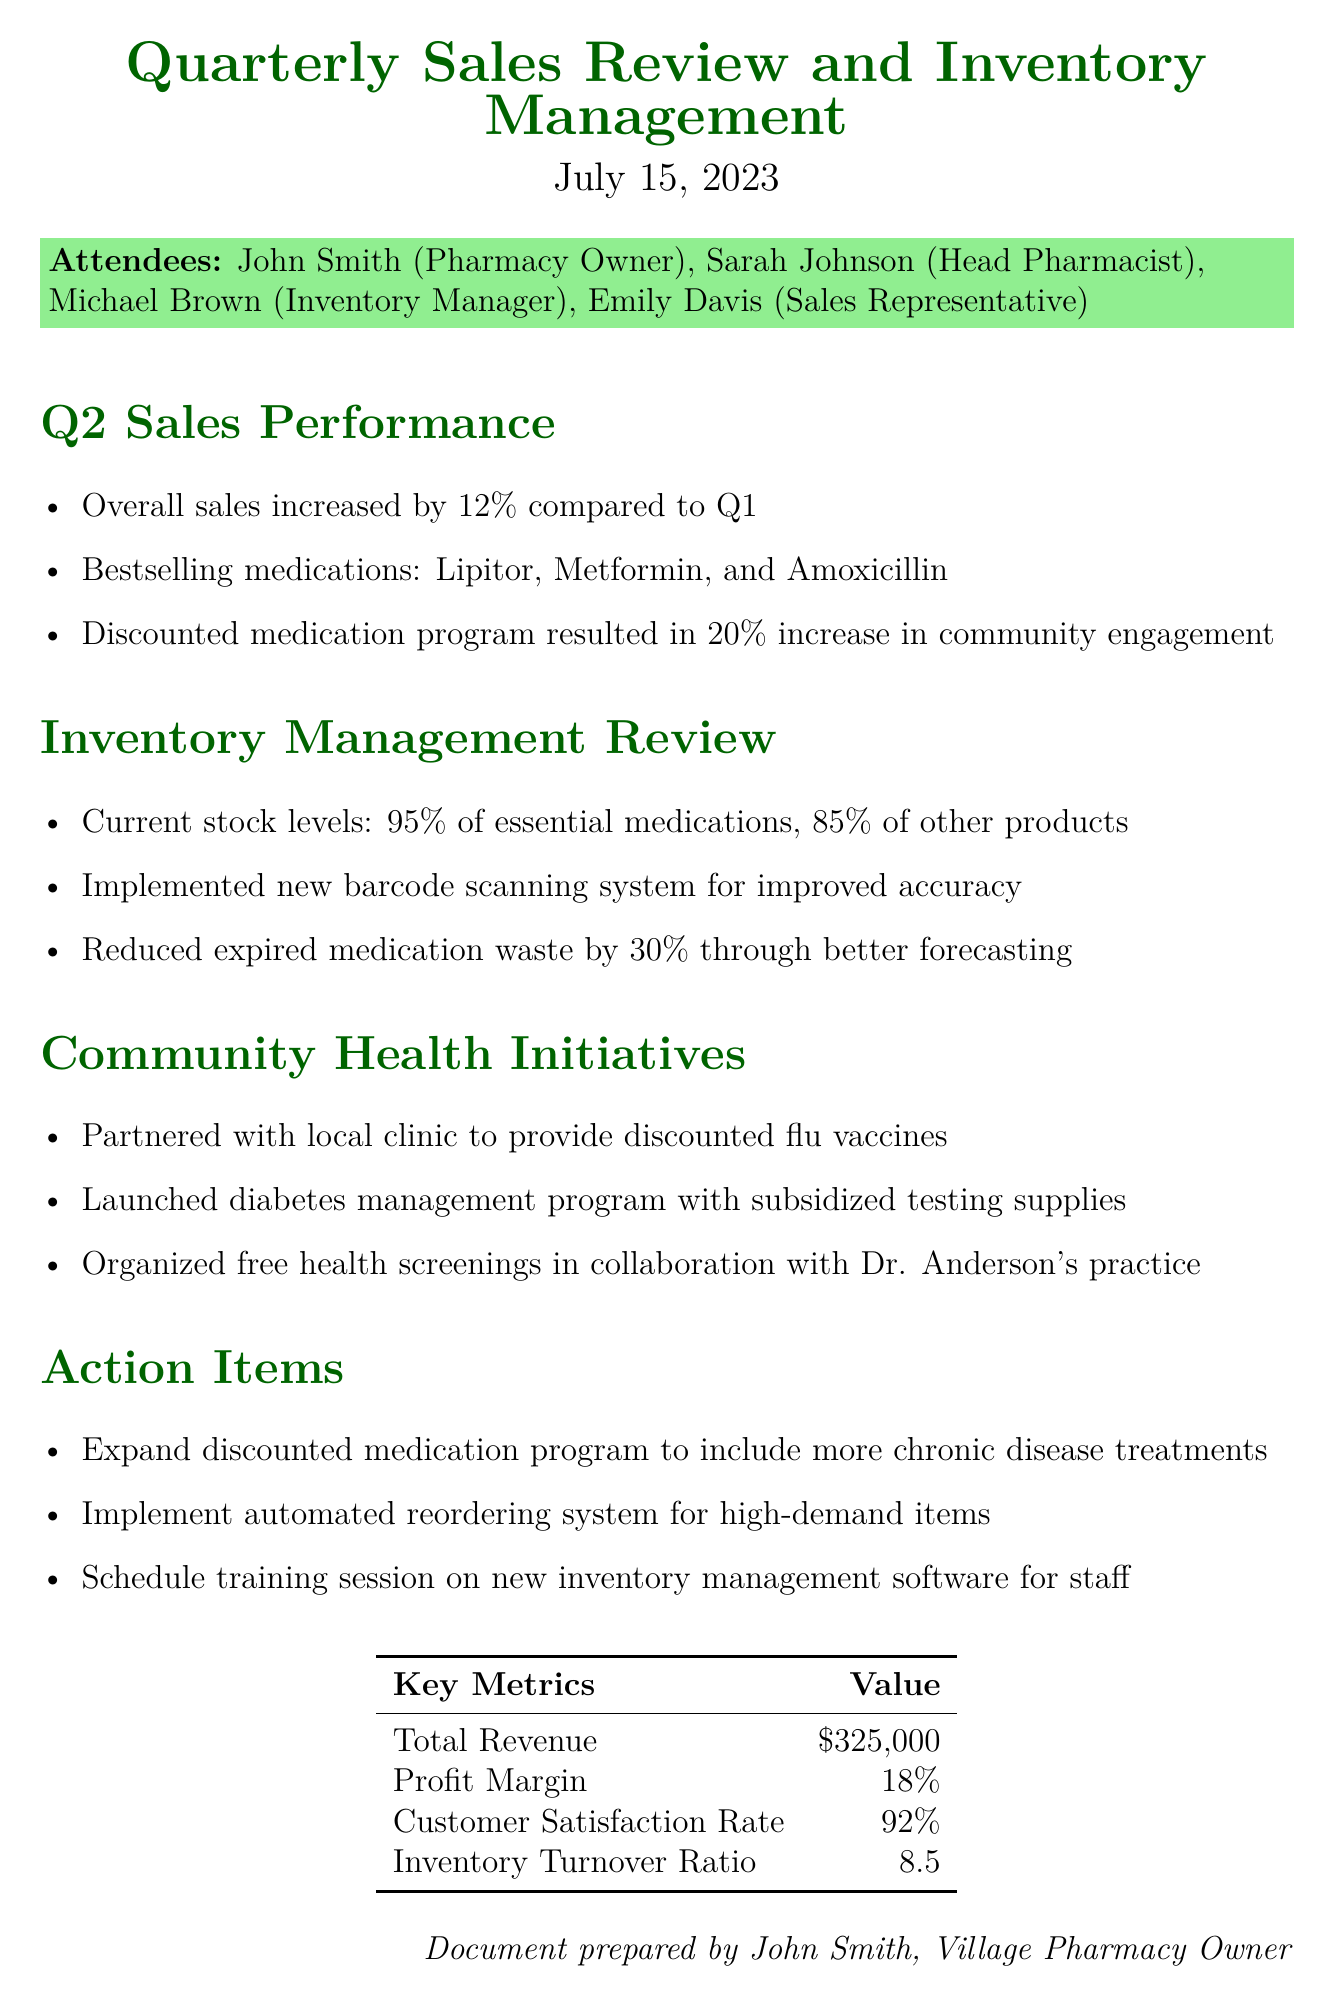What was the percentage increase in overall sales compared to Q1? The document states that overall sales increased by 12% compared to Q1.
Answer: 12% Who is the head pharmacist? Sarah Johnson is listed as the head pharmacist among the attendees.
Answer: Sarah Johnson What are the bestselling medications mentioned? The document lists Lipitor, Metformin, and Amoxicillin as the bestselling medications.
Answer: Lipitor, Metformin, Amoxicillin What was the profit margin reported in the key metrics? The profit margin is specifically stated in the key metrics section as 18%.
Answer: 18% How much did the discounted medication program increase community engagement? The document indicates a 20% increase in community engagement due to the discounted medication program.
Answer: 20% What action item is suggested regarding chronic disease treatments? The document suggests expanding the discounted medication program to include more chronic disease treatments.
Answer: Expand discounted medication program What percentage of essential medications are currently in stock? The inventory management review states that current stock levels are at 95% of essential medications.
Answer: 95% What system was implemented for improved inventory accuracy? The document mentions the implementation of a new barcode scanning system for improved accuracy.
Answer: Barcode scanning system How many attendees were present at the meeting? The document lists four attendees present at the meeting.
Answer: Four 